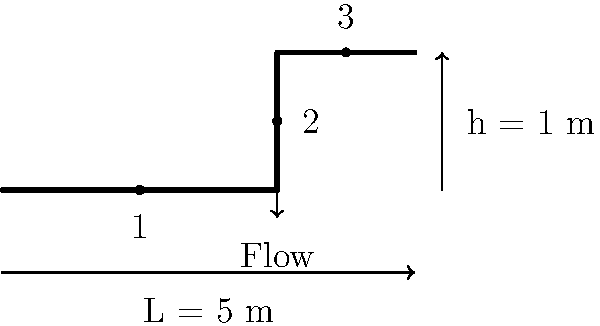Ellen and her colleague are discussing a plumbing problem at home while taking a break from watching their favorite show. They decide to calculate the pressure drop in the pipe system shown above. The pipe has a diameter of 2 cm and a flow rate of 0.001 m³/s. There is one 90° elbow at point 2 and one gate valve at point 3. The pipe material is PVC with a roughness of 0.0015 mm. Calculate the total pressure drop in the system, assuming water at 20°C (density = 998 kg/m³, viscosity = 0.001 Pa·s) is flowing through the pipe. Use the Darcy-Weisbach equation and appropriate minor loss coefficients. Let's approach this step-by-step:

1) First, calculate the velocity in the pipe:
   $$ v = \frac{Q}{A} = \frac{0.001}{\pi (0.01)^2} = 3.18 \text{ m/s} $$

2) Calculate the Reynolds number:
   $$ Re = \frac{\rho v D}{\mu} = \frac{998 \cdot 3.18 \cdot 0.02}{0.001} = 63,523 $$

3) Calculate the relative roughness:
   $$ \frac{\epsilon}{D} = \frac{0.0015 \cdot 10^{-3}}{0.02} = 7.5 \cdot 10^{-5} $$

4) Use the Colebrook equation to find the friction factor (iteratively):
   $$ \frac{1}{\sqrt{f}} = -2\log_{10}\left(\frac{\epsilon/D}{3.7} + \frac{2.51}{Re\sqrt{f}}\right) $$
   This gives $f \approx 0.02$

5) Calculate the major losses using the Darcy-Weisbach equation:
   $$ h_L = f \frac{L}{D} \frac{v^2}{2g} = 0.02 \cdot \frac{5}{0.02} \cdot \frac{3.18^2}{2 \cdot 9.81} = 2.58 \text{ m} $$

6) Calculate minor losses:
   For 90° elbow, $K_e = 0.3$
   For gate valve, $K_v = 0.2$
   $$ h_m = (K_e + K_v) \frac{v^2}{2g} = (0.3 + 0.2) \cdot \frac{3.18^2}{2 \cdot 9.81} = 0.26 \text{ m} $$

7) Total head loss:
   $$ h_{\text{total}} = h_L + h_m = 2.58 + 0.26 = 2.84 \text{ m} $$

8) Convert to pressure drop:
   $$ \Delta P = \rho g h_{\text{total}} = 998 \cdot 9.81 \cdot 2.84 = 27,786 \text{ Pa} $$
Answer: 27.8 kPa 